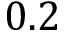Convert formula to latex. <formula><loc_0><loc_0><loc_500><loc_500>0 . 2</formula> 